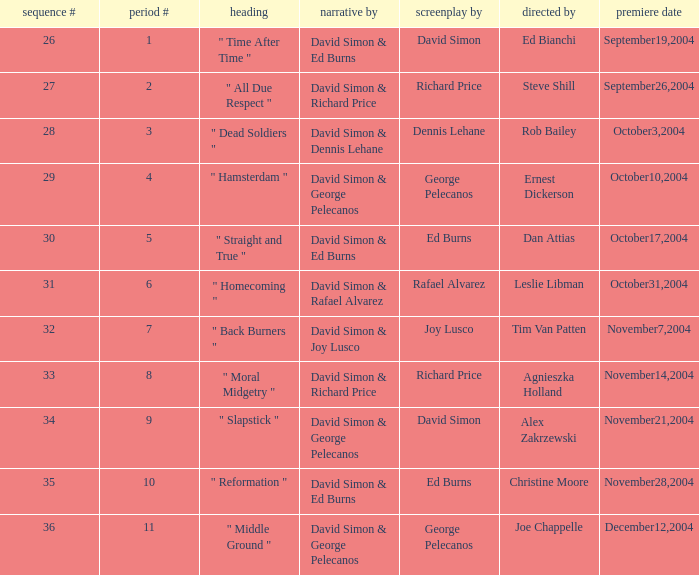Who is the teleplay by when the director is Rob Bailey? Dennis Lehane. 